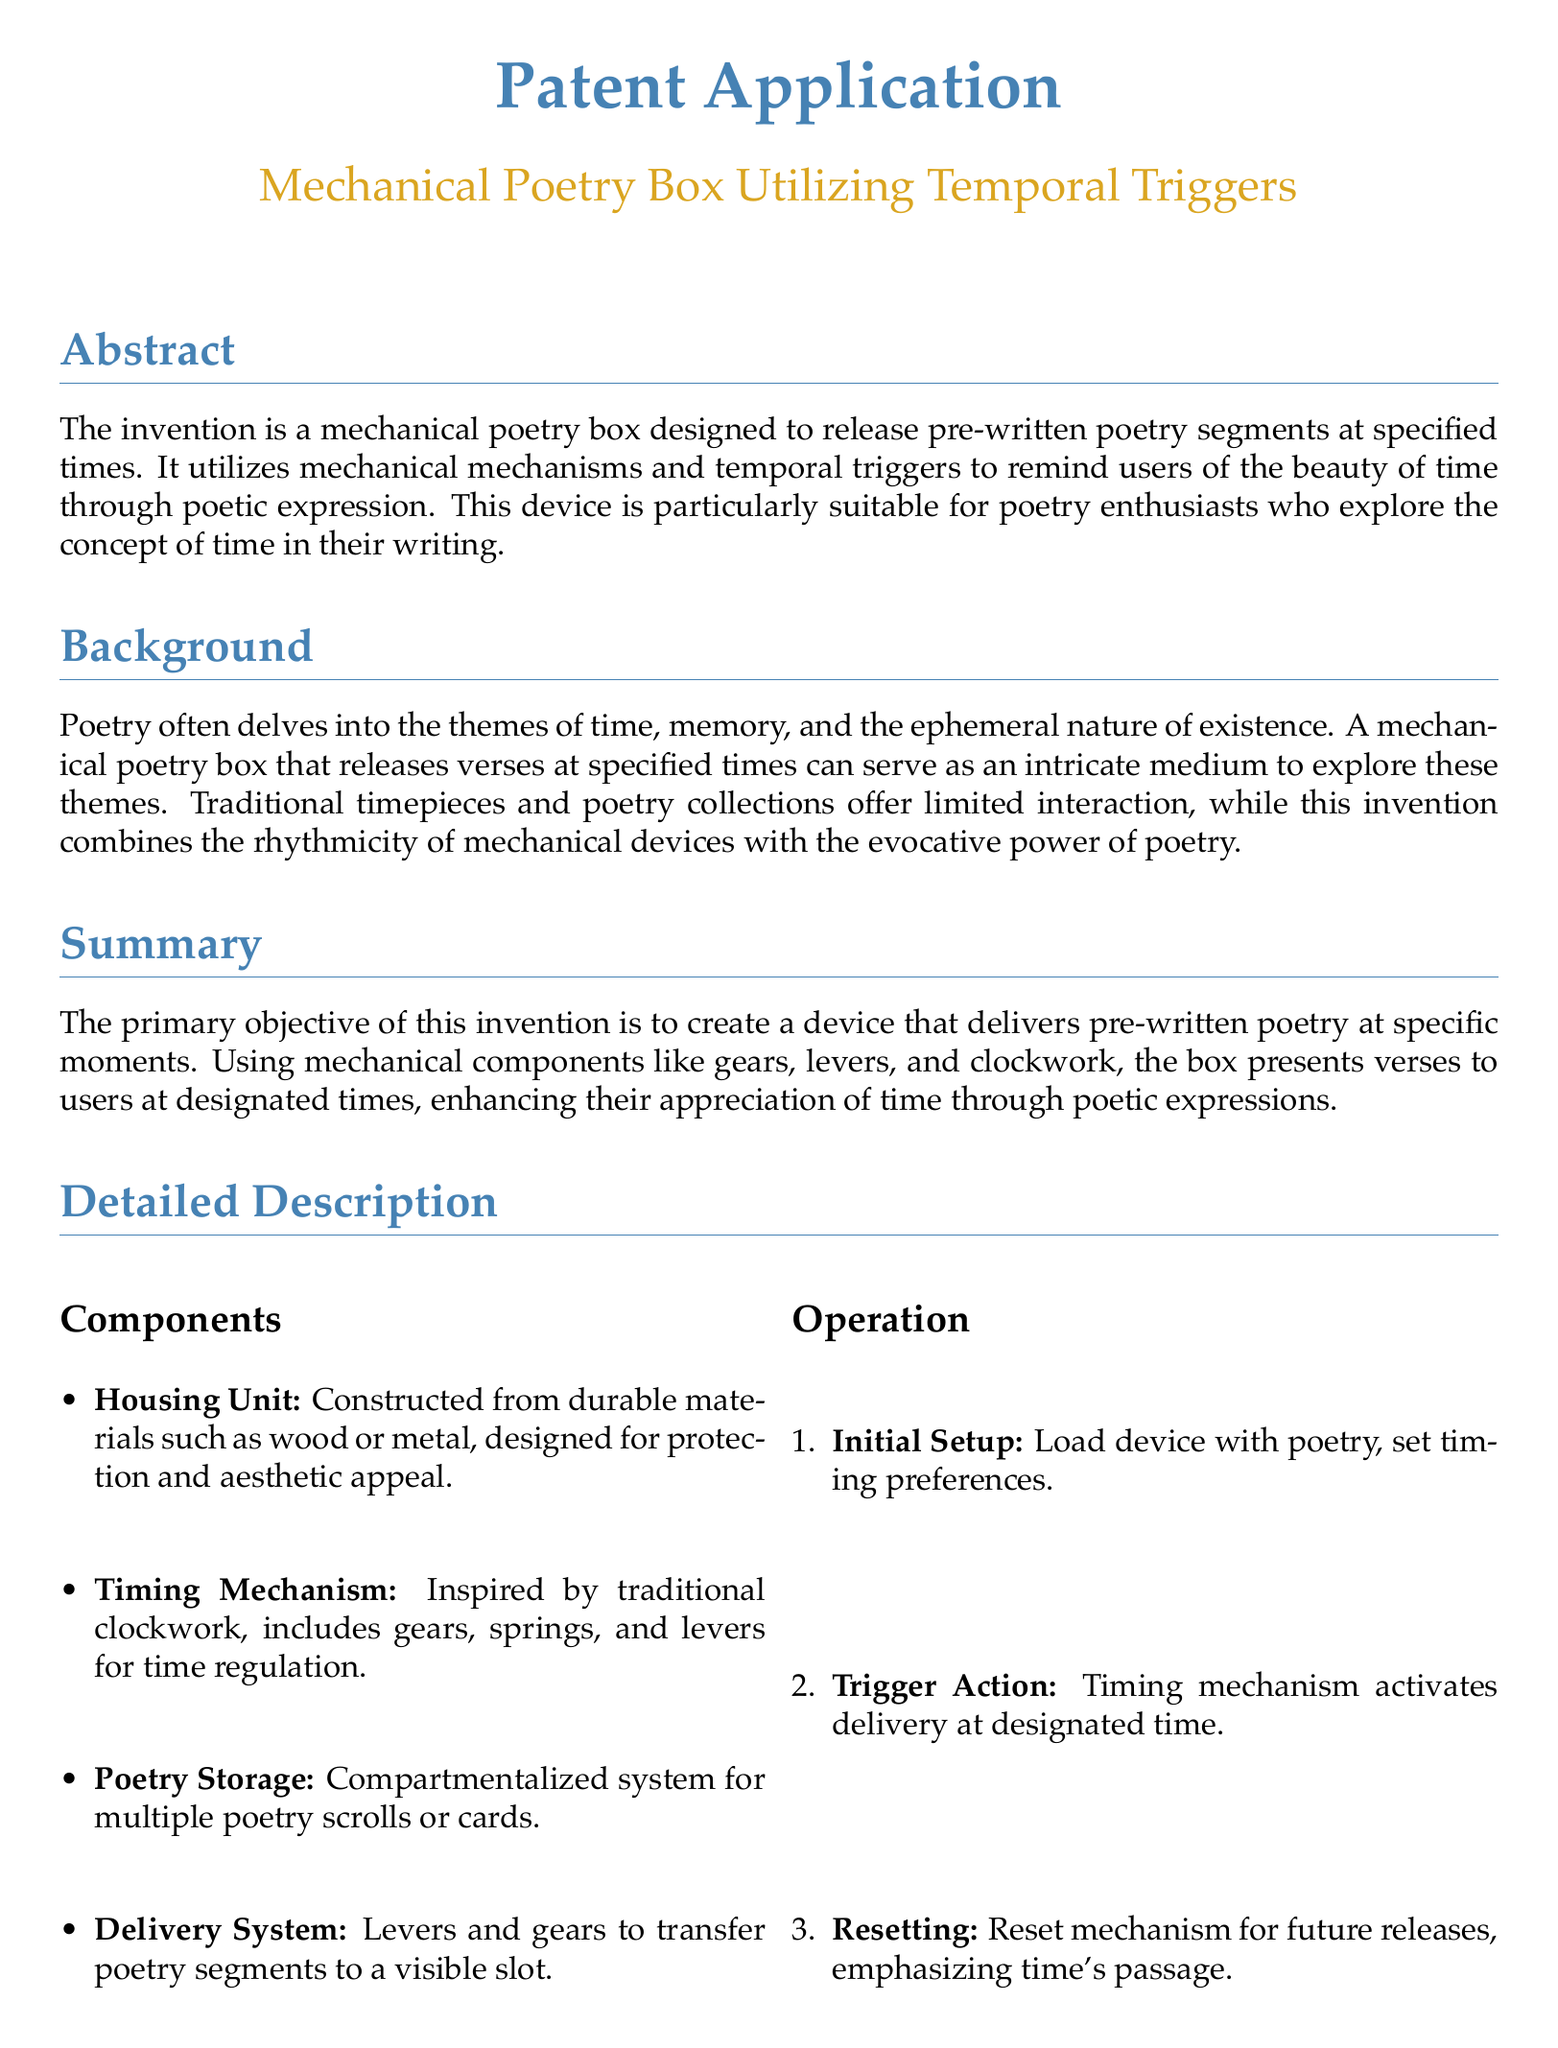What is the title of the patent? The title of the patent is mentioned at the top of the document and is focused on the mechanical poetry box.
Answer: Mechanical Poetry Box Utilizing Temporal Triggers What is the primary objective of the invention? The objective is stated in the summary section of the document, highlighting the desire to deliver poetry at specific times.
Answer: To create a device that delivers pre-written poetry at specific moments What materials are suggested for the housing unit? The materials for the housing unit are specified in the components section, indicating both durability and aesthetic appeal.
Answer: Wood or metal How does the timing mechanism operate? The operation of the timing mechanism is briefly discussed, describing it as employing certain mechanical components.
Answer: Gears, springs, and levers What is one example of how the device can be used? Examples are provided in a dedicated section, illustrating potential uses for the poetry box.
Answer: Daily morning verse What type of storage system does the device use? The document mentions the structure used for poetry collection, focusing on organization.
Answer: Compartmentalized system How many claims are made in the document? The total number of claims is listed in the claims section, indicating various aspects of the invention.
Answer: Five What aspect does the device enhance for users? This enhancement is stated in the summary, reflecting the device's purpose regarding poetic expressions.
Answer: Appreciation of time What section discusses the operational steps of the device? The operation of the device is detailed in a specific section that outlines the process from initial setup to resetting.
Answer: Operation 